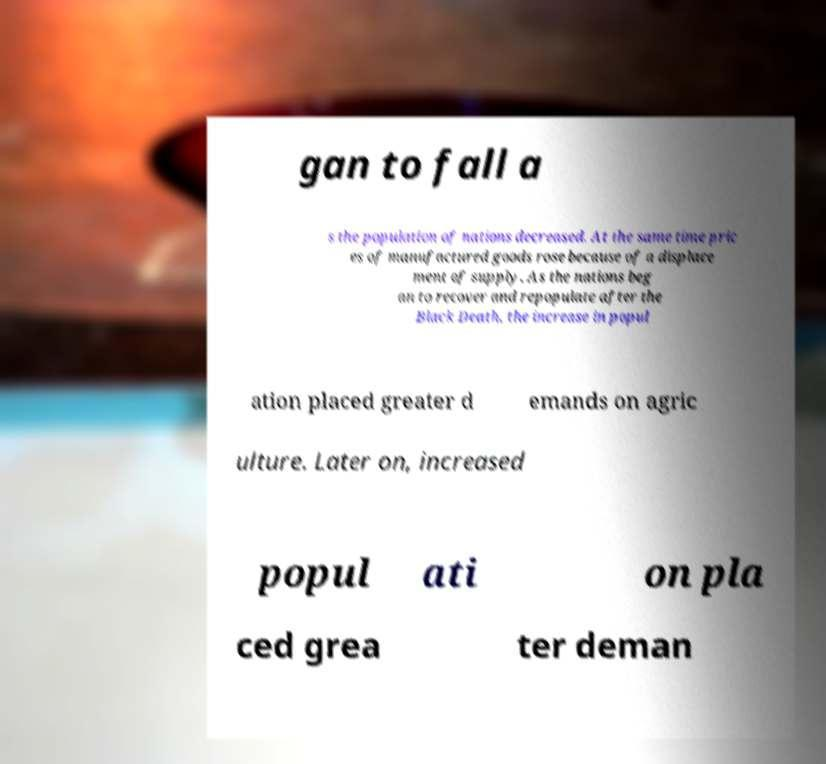Can you accurately transcribe the text from the provided image for me? gan to fall a s the population of nations decreased. At the same time pric es of manufactured goods rose because of a displace ment of supply. As the nations beg an to recover and repopulate after the Black Death, the increase in popul ation placed greater d emands on agric ulture. Later on, increased popul ati on pla ced grea ter deman 